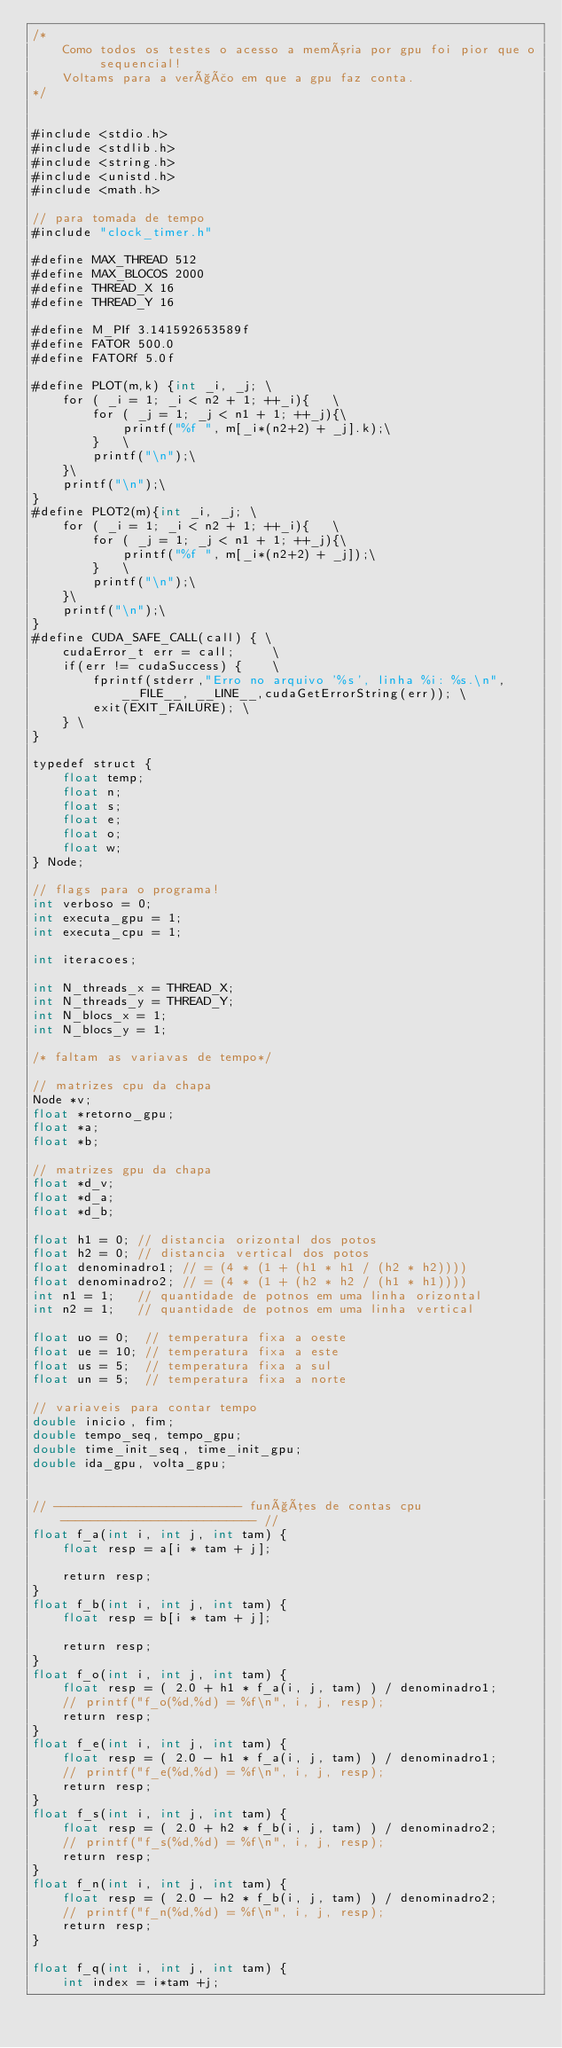Convert code to text. <code><loc_0><loc_0><loc_500><loc_500><_Cuda_>/*
	Como todos os testes o acesso a memória por gpu foi pior que o sequencial!
	Voltams para a verção em que a gpu faz conta.
*/


#include <stdio.h>
#include <stdlib.h>
#include <string.h>
#include <unistd.h>
#include <math.h>

// para tomada de tempo
#include "clock_timer.h"

#define MAX_THREAD 512
#define MAX_BLOCOS 2000
#define THREAD_X 16
#define THREAD_Y 16

#define M_PIf 3.141592653589f
#define FATOR 500.0
#define FATORf 5.0f

#define PLOT(m,k) {int _i, _j; \
	for ( _i = 1; _i < n2 + 1; ++_i){	\
		for ( _j = 1; _j < n1 + 1; ++_j){\
			printf("%f ", m[_i*(n2+2) + _j].k);\
		}	\
		printf("\n");\
	}\
	printf("\n");\
}
#define PLOT2(m){int _i, _j; \
	for ( _i = 1; _i < n2 + 1; ++_i){	\
		for ( _j = 1; _j < n1 + 1; ++_j){\
			printf("%f ", m[_i*(n2+2) + _j]);\
		}	\
		printf("\n");\
	}\
	printf("\n");\
}
#define CUDA_SAFE_CALL(call) { \
	cudaError_t err = call;     \
	if(err != cudaSuccess) {    \
		fprintf(stderr,"Erro no arquivo '%s', linha %i: %s.\n",__FILE__, __LINE__,cudaGetErrorString(err)); \
		exit(EXIT_FAILURE); \
	} \
}

typedef struct {
	float temp;
	float n;
	float s;
	float e;
	float o;
	float w;
} Node;

// flags para o programa!
int verboso = 0;
int executa_gpu = 1;
int executa_cpu = 1;

int iteracoes;

int N_threads_x = THREAD_X;
int N_threads_y = THREAD_Y;
int N_blocs_x = 1;
int N_blocs_y = 1;

/* faltam as variavas de tempo*/

// matrizes cpu da chapa
Node *v;
float *retorno_gpu;
float *a;
float *b;

// matrizes gpu da chapa
float *d_v;
float *d_a;
float *d_b;

float h1 = 0; // distancia orizontal dos potos
float h2 = 0; // distancia vertical dos potos
float denominadro1; // = (4 * (1 + (h1 * h1 / (h2 * h2))))
float denominadro2; // = (4 * (1 + (h2 * h2 / (h1 * h1))))
int n1 = 1;   // quantidade de potnos em uma linha orizontal
int n2 = 1;   // quantidade de potnos em uma linha vertical

float uo = 0;  // temperatura fixa a oeste
float ue = 10; // temperatura fixa a este
float us = 5;  // temperatura fixa a sul
float un = 5;  // temperatura fixa a norte

// variaveis para contar tempo
double inicio, fim;
double tempo_seq, tempo_gpu;
double time_init_seq, time_init_gpu;
double ida_gpu, volta_gpu;


// ------------------------- funções de contas cpu -------------------------- //
float f_a(int i, int j, int tam) {
	float resp = a[i * tam + j];

	return resp;
}
float f_b(int i, int j, int tam) {
	float resp = b[i * tam + j];

	return resp;
}
float f_o(int i, int j, int tam) {
	float resp = ( 2.0 + h1 * f_a(i, j, tam) ) / denominadro1;
	// printf("f_o(%d,%d) = %f\n", i, j, resp);
	return resp;
}
float f_e(int i, int j, int tam) {
	float resp = ( 2.0 - h1 * f_a(i, j, tam) ) / denominadro1;
	// printf("f_e(%d,%d) = %f\n", i, j, resp);
	return resp;
}
float f_s(int i, int j, int tam) {
	float resp = ( 2.0 + h2 * f_b(i, j, tam) ) / denominadro2;
	// printf("f_s(%d,%d) = %f\n", i, j, resp);
	return resp;
}
float f_n(int i, int j, int tam) {
	float resp = ( 2.0 - h2 * f_b(i, j, tam) ) / denominadro2;
	// printf("f_n(%d,%d) = %f\n", i, j, resp);
	return resp;
}

float f_q(int i, int j, int tam) {
	int index = i*tam +j;</code> 